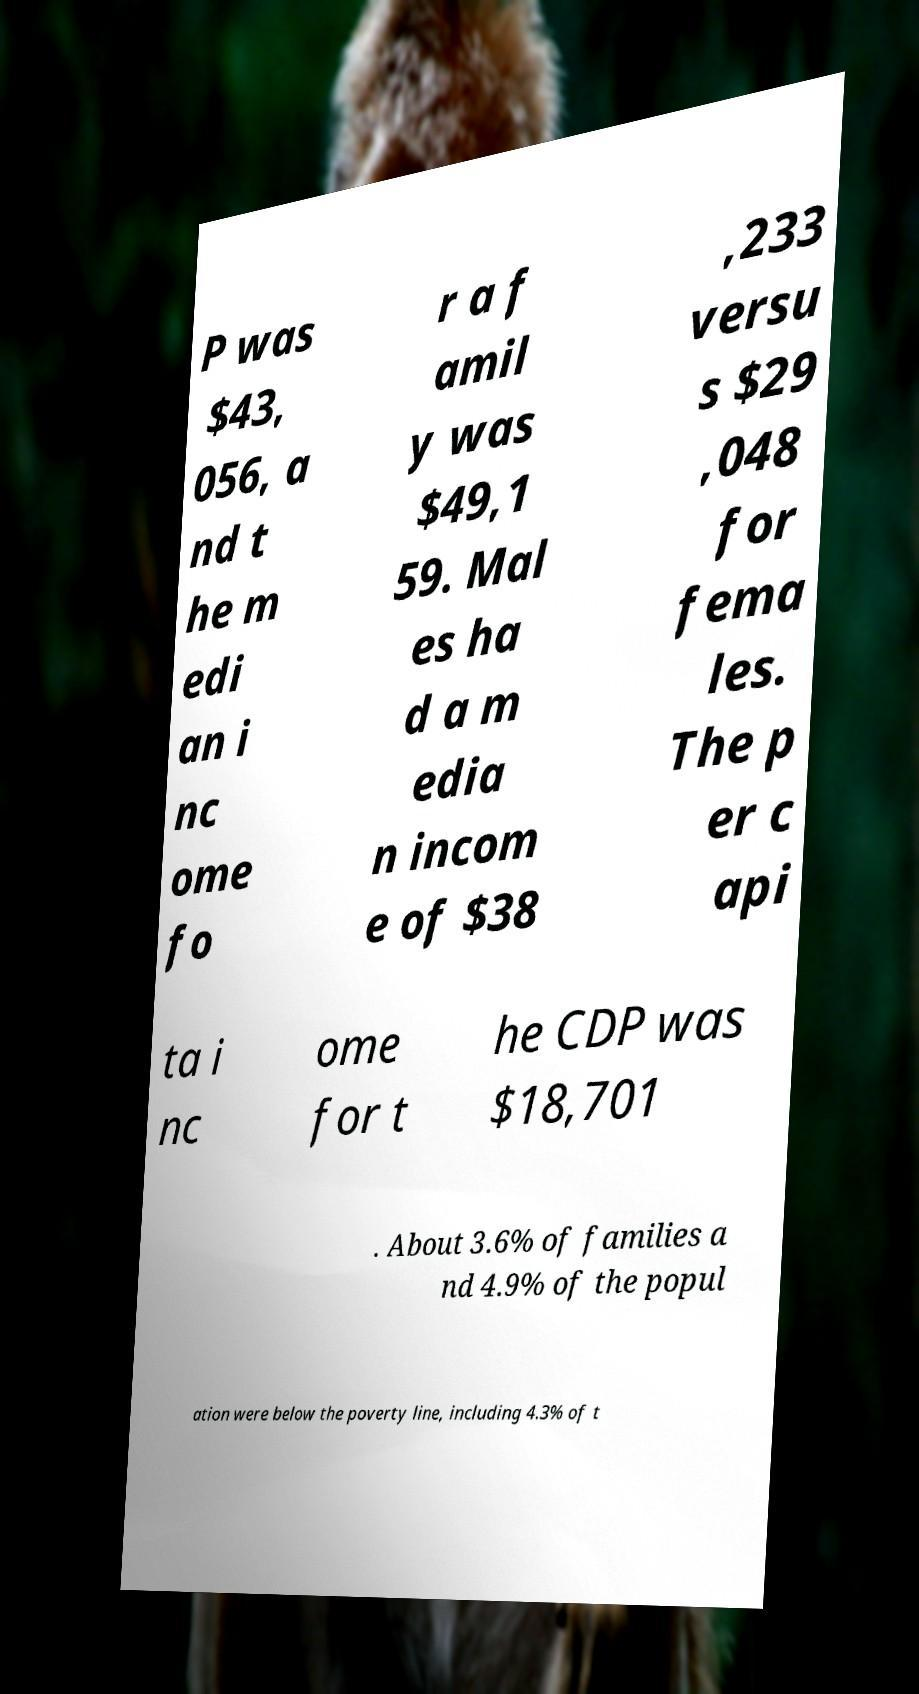Can you accurately transcribe the text from the provided image for me? P was $43, 056, a nd t he m edi an i nc ome fo r a f amil y was $49,1 59. Mal es ha d a m edia n incom e of $38 ,233 versu s $29 ,048 for fema les. The p er c api ta i nc ome for t he CDP was $18,701 . About 3.6% of families a nd 4.9% of the popul ation were below the poverty line, including 4.3% of t 